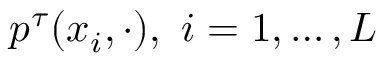Convert formula to latex. <formula><loc_0><loc_0><loc_500><loc_500>p ^ { \tau } ( x _ { i } , \cdot ) , i = 1 , \dots , L</formula> 